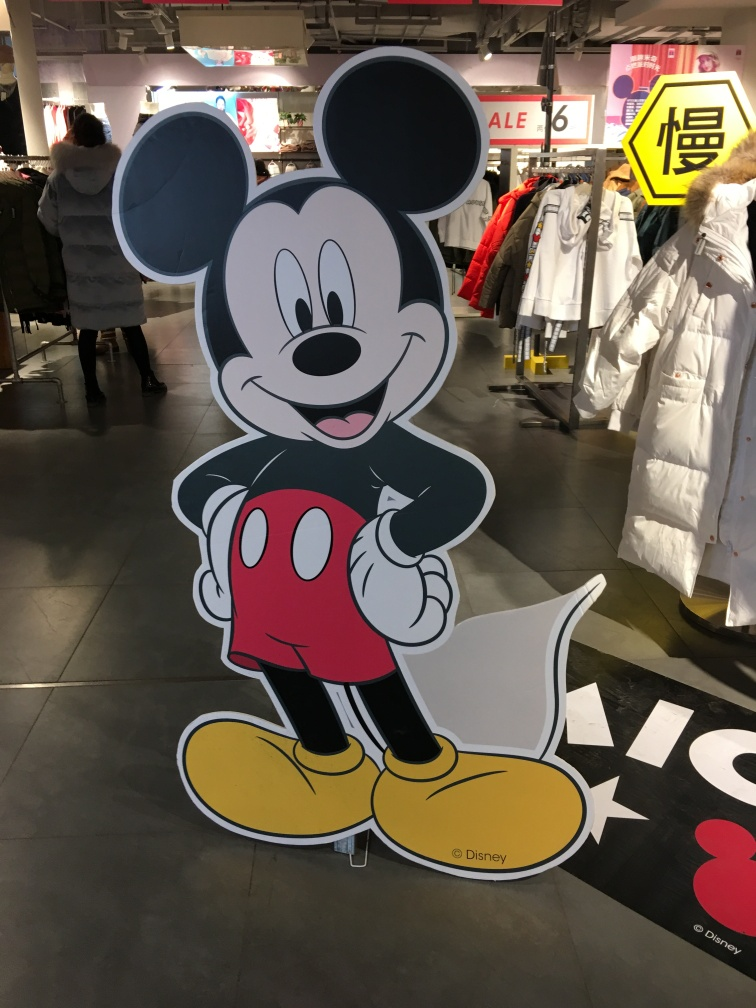What cultural significance does this character hold? This character is a widely recognized symbol of animation and pop culture, often associated with childhood, entertainment, and a large media franchise. Its appearance in this setting likely evokes nostalgia and joy among a wide audience. 